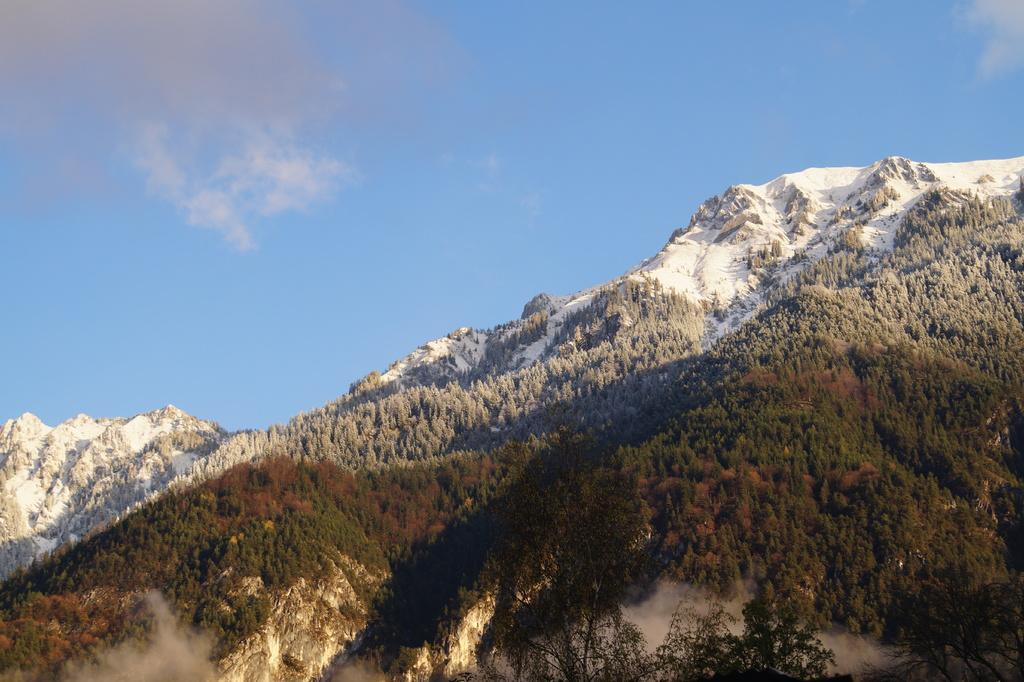What type of landscape is shown in the image? The image depicts a mountain forest. Can you describe the sky in the image? The sky is slightly cloudy and blue. What type of disease is affecting the trees in the image? There is no indication of any disease affecting the trees in the image; they appear to be healthy. What form does the interest rate take in the image? There is no mention of interest rates or financial information in the image; it depicts a mountain forest and a blue sky. 